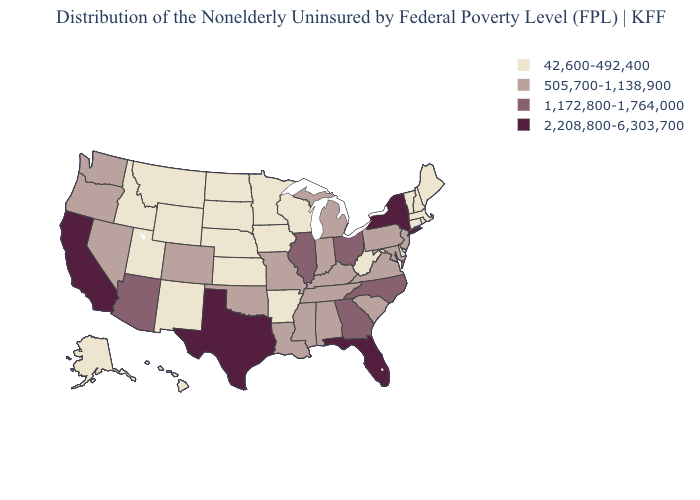Name the states that have a value in the range 2,208,800-6,303,700?
Answer briefly. California, Florida, New York, Texas. Name the states that have a value in the range 42,600-492,400?
Answer briefly. Alaska, Arkansas, Connecticut, Delaware, Hawaii, Idaho, Iowa, Kansas, Maine, Massachusetts, Minnesota, Montana, Nebraska, New Hampshire, New Mexico, North Dakota, Rhode Island, South Dakota, Utah, Vermont, West Virginia, Wisconsin, Wyoming. Among the states that border Massachusetts , which have the lowest value?
Quick response, please. Connecticut, New Hampshire, Rhode Island, Vermont. Is the legend a continuous bar?
Give a very brief answer. No. What is the lowest value in the West?
Keep it brief. 42,600-492,400. Does Vermont have the lowest value in the USA?
Be succinct. Yes. Among the states that border Massachusetts , does New York have the lowest value?
Give a very brief answer. No. Name the states that have a value in the range 2,208,800-6,303,700?
Answer briefly. California, Florida, New York, Texas. Name the states that have a value in the range 42,600-492,400?
Keep it brief. Alaska, Arkansas, Connecticut, Delaware, Hawaii, Idaho, Iowa, Kansas, Maine, Massachusetts, Minnesota, Montana, Nebraska, New Hampshire, New Mexico, North Dakota, Rhode Island, South Dakota, Utah, Vermont, West Virginia, Wisconsin, Wyoming. What is the value of Wyoming?
Answer briefly. 42,600-492,400. What is the value of Arkansas?
Be succinct. 42,600-492,400. What is the value of Georgia?
Concise answer only. 1,172,800-1,764,000. Name the states that have a value in the range 2,208,800-6,303,700?
Quick response, please. California, Florida, New York, Texas. What is the lowest value in states that border Arizona?
Concise answer only. 42,600-492,400. Does the first symbol in the legend represent the smallest category?
Concise answer only. Yes. 